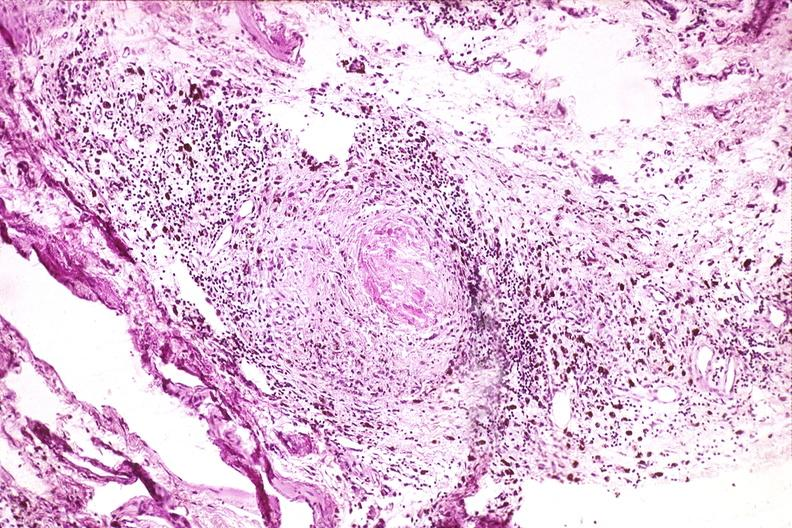s pinworm present?
Answer the question using a single word or phrase. No 